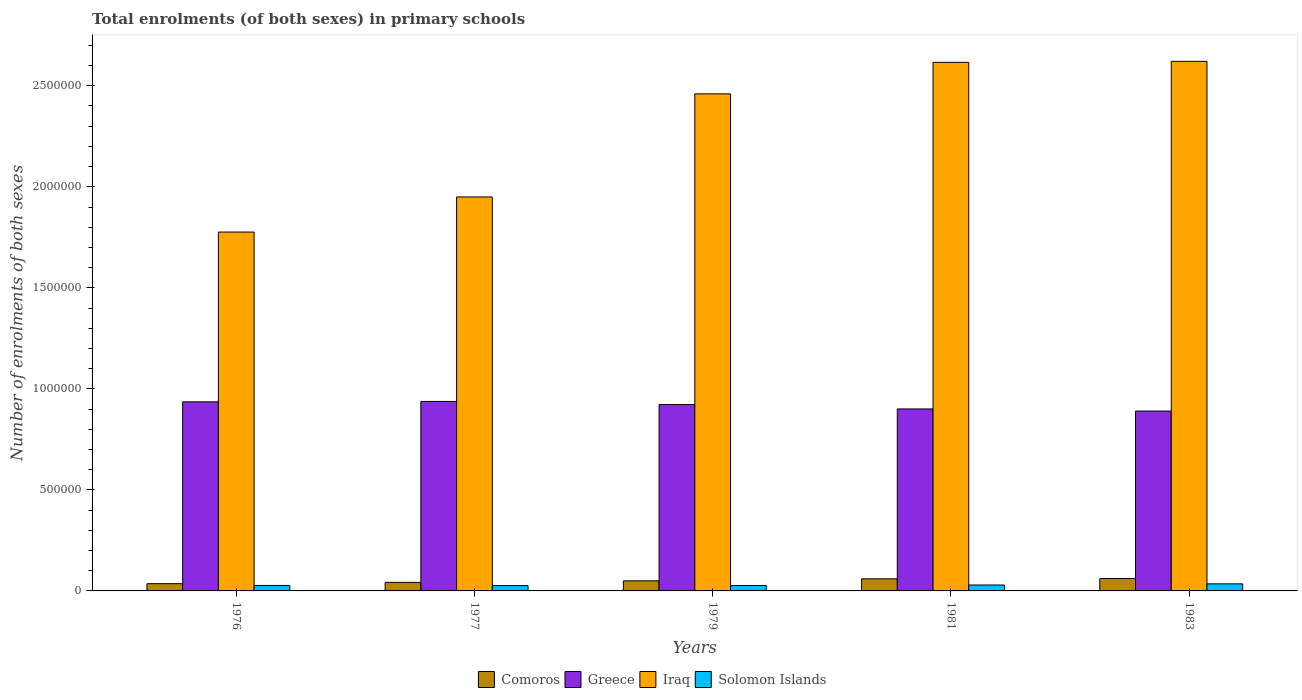How many different coloured bars are there?
Give a very brief answer. 4. How many groups of bars are there?
Offer a very short reply. 5. How many bars are there on the 3rd tick from the right?
Give a very brief answer. 4. What is the label of the 1st group of bars from the left?
Your answer should be very brief. 1976. In how many cases, is the number of bars for a given year not equal to the number of legend labels?
Your answer should be very brief. 0. What is the number of enrolments in primary schools in Comoros in 1979?
Offer a very short reply. 4.99e+04. Across all years, what is the maximum number of enrolments in primary schools in Iraq?
Your response must be concise. 2.62e+06. Across all years, what is the minimum number of enrolments in primary schools in Iraq?
Keep it short and to the point. 1.78e+06. In which year was the number of enrolments in primary schools in Iraq minimum?
Offer a terse response. 1976. What is the total number of enrolments in primary schools in Iraq in the graph?
Give a very brief answer. 1.14e+07. What is the difference between the number of enrolments in primary schools in Iraq in 1977 and that in 1979?
Offer a terse response. -5.10e+05. What is the difference between the number of enrolments in primary schools in Iraq in 1977 and the number of enrolments in primary schools in Greece in 1979?
Make the answer very short. 1.03e+06. What is the average number of enrolments in primary schools in Solomon Islands per year?
Your response must be concise. 2.89e+04. In the year 1979, what is the difference between the number of enrolments in primary schools in Solomon Islands and number of enrolments in primary schools in Comoros?
Your answer should be very brief. -2.30e+04. In how many years, is the number of enrolments in primary schools in Iraq greater than 2500000?
Give a very brief answer. 2. What is the ratio of the number of enrolments in primary schools in Iraq in 1976 to that in 1977?
Ensure brevity in your answer.  0.91. Is the number of enrolments in primary schools in Comoros in 1979 less than that in 1983?
Offer a very short reply. Yes. What is the difference between the highest and the second highest number of enrolments in primary schools in Iraq?
Offer a terse response. 4973. What is the difference between the highest and the lowest number of enrolments in primary schools in Comoros?
Give a very brief answer. 2.57e+04. Is the sum of the number of enrolments in primary schools in Greece in 1979 and 1983 greater than the maximum number of enrolments in primary schools in Solomon Islands across all years?
Provide a succinct answer. Yes. Is it the case that in every year, the sum of the number of enrolments in primary schools in Greece and number of enrolments in primary schools in Comoros is greater than the sum of number of enrolments in primary schools in Solomon Islands and number of enrolments in primary schools in Iraq?
Provide a short and direct response. Yes. What does the 1st bar from the left in 1983 represents?
Your answer should be very brief. Comoros. What does the 2nd bar from the right in 1976 represents?
Make the answer very short. Iraq. How many bars are there?
Offer a very short reply. 20. Are all the bars in the graph horizontal?
Provide a succinct answer. No. Are the values on the major ticks of Y-axis written in scientific E-notation?
Keep it short and to the point. No. Where does the legend appear in the graph?
Your answer should be compact. Bottom center. How are the legend labels stacked?
Offer a terse response. Horizontal. What is the title of the graph?
Make the answer very short. Total enrolments (of both sexes) in primary schools. What is the label or title of the X-axis?
Offer a very short reply. Years. What is the label or title of the Y-axis?
Provide a short and direct response. Number of enrolments of both sexes. What is the Number of enrolments of both sexes in Comoros in 1976?
Give a very brief answer. 3.58e+04. What is the Number of enrolments of both sexes in Greece in 1976?
Your answer should be compact. 9.36e+05. What is the Number of enrolments of both sexes in Iraq in 1976?
Provide a short and direct response. 1.78e+06. What is the Number of enrolments of both sexes of Solomon Islands in 1976?
Offer a terse response. 2.70e+04. What is the Number of enrolments of both sexes in Comoros in 1977?
Offer a very short reply. 4.23e+04. What is the Number of enrolments of both sexes of Greece in 1977?
Provide a short and direct response. 9.38e+05. What is the Number of enrolments of both sexes in Iraq in 1977?
Your answer should be compact. 1.95e+06. What is the Number of enrolments of both sexes in Solomon Islands in 1977?
Give a very brief answer. 2.64e+04. What is the Number of enrolments of both sexes of Comoros in 1979?
Give a very brief answer. 4.99e+04. What is the Number of enrolments of both sexes in Greece in 1979?
Your answer should be compact. 9.22e+05. What is the Number of enrolments of both sexes in Iraq in 1979?
Make the answer very short. 2.46e+06. What is the Number of enrolments of both sexes in Solomon Islands in 1979?
Make the answer very short. 2.70e+04. What is the Number of enrolments of both sexes in Comoros in 1981?
Give a very brief answer. 5.97e+04. What is the Number of enrolments of both sexes in Greece in 1981?
Provide a succinct answer. 9.01e+05. What is the Number of enrolments of both sexes of Iraq in 1981?
Your answer should be compact. 2.62e+06. What is the Number of enrolments of both sexes in Solomon Islands in 1981?
Your response must be concise. 2.93e+04. What is the Number of enrolments of both sexes of Comoros in 1983?
Keep it short and to the point. 6.15e+04. What is the Number of enrolments of both sexes in Greece in 1983?
Ensure brevity in your answer.  8.90e+05. What is the Number of enrolments of both sexes in Iraq in 1983?
Provide a succinct answer. 2.62e+06. What is the Number of enrolments of both sexes in Solomon Islands in 1983?
Your answer should be very brief. 3.50e+04. Across all years, what is the maximum Number of enrolments of both sexes of Comoros?
Offer a very short reply. 6.15e+04. Across all years, what is the maximum Number of enrolments of both sexes of Greece?
Provide a succinct answer. 9.38e+05. Across all years, what is the maximum Number of enrolments of both sexes of Iraq?
Your answer should be very brief. 2.62e+06. Across all years, what is the maximum Number of enrolments of both sexes of Solomon Islands?
Offer a terse response. 3.50e+04. Across all years, what is the minimum Number of enrolments of both sexes of Comoros?
Offer a terse response. 3.58e+04. Across all years, what is the minimum Number of enrolments of both sexes of Greece?
Your answer should be compact. 8.90e+05. Across all years, what is the minimum Number of enrolments of both sexes in Iraq?
Offer a very short reply. 1.78e+06. Across all years, what is the minimum Number of enrolments of both sexes in Solomon Islands?
Offer a very short reply. 2.64e+04. What is the total Number of enrolments of both sexes of Comoros in the graph?
Provide a succinct answer. 2.49e+05. What is the total Number of enrolments of both sexes in Greece in the graph?
Give a very brief answer. 4.59e+06. What is the total Number of enrolments of both sexes in Iraq in the graph?
Provide a succinct answer. 1.14e+07. What is the total Number of enrolments of both sexes in Solomon Islands in the graph?
Offer a very short reply. 1.45e+05. What is the difference between the Number of enrolments of both sexes in Comoros in 1976 and that in 1977?
Your response must be concise. -6520. What is the difference between the Number of enrolments of both sexes of Greece in 1976 and that in 1977?
Your answer should be compact. -2050. What is the difference between the Number of enrolments of both sexes in Iraq in 1976 and that in 1977?
Your answer should be compact. -1.74e+05. What is the difference between the Number of enrolments of both sexes of Solomon Islands in 1976 and that in 1977?
Provide a succinct answer. 631. What is the difference between the Number of enrolments of both sexes of Comoros in 1976 and that in 1979?
Your response must be concise. -1.41e+04. What is the difference between the Number of enrolments of both sexes of Greece in 1976 and that in 1979?
Keep it short and to the point. 1.33e+04. What is the difference between the Number of enrolments of both sexes in Iraq in 1976 and that in 1979?
Offer a terse response. -6.84e+05. What is the difference between the Number of enrolments of both sexes of Solomon Islands in 1976 and that in 1979?
Provide a succinct answer. 48. What is the difference between the Number of enrolments of both sexes of Comoros in 1976 and that in 1981?
Provide a short and direct response. -2.39e+04. What is the difference between the Number of enrolments of both sexes in Greece in 1976 and that in 1981?
Your answer should be very brief. 3.51e+04. What is the difference between the Number of enrolments of both sexes of Iraq in 1976 and that in 1981?
Ensure brevity in your answer.  -8.40e+05. What is the difference between the Number of enrolments of both sexes of Solomon Islands in 1976 and that in 1981?
Make the answer very short. -2232. What is the difference between the Number of enrolments of both sexes of Comoros in 1976 and that in 1983?
Your answer should be compact. -2.57e+04. What is the difference between the Number of enrolments of both sexes of Greece in 1976 and that in 1983?
Make the answer very short. 4.56e+04. What is the difference between the Number of enrolments of both sexes of Iraq in 1976 and that in 1983?
Make the answer very short. -8.45e+05. What is the difference between the Number of enrolments of both sexes of Solomon Islands in 1976 and that in 1983?
Provide a succinct answer. -7932. What is the difference between the Number of enrolments of both sexes in Comoros in 1977 and that in 1979?
Make the answer very short. -7602. What is the difference between the Number of enrolments of both sexes of Greece in 1977 and that in 1979?
Your answer should be very brief. 1.54e+04. What is the difference between the Number of enrolments of both sexes of Iraq in 1977 and that in 1979?
Ensure brevity in your answer.  -5.10e+05. What is the difference between the Number of enrolments of both sexes of Solomon Islands in 1977 and that in 1979?
Provide a succinct answer. -583. What is the difference between the Number of enrolments of both sexes in Comoros in 1977 and that in 1981?
Keep it short and to the point. -1.74e+04. What is the difference between the Number of enrolments of both sexes in Greece in 1977 and that in 1981?
Offer a very short reply. 3.71e+04. What is the difference between the Number of enrolments of both sexes of Iraq in 1977 and that in 1981?
Give a very brief answer. -6.66e+05. What is the difference between the Number of enrolments of both sexes in Solomon Islands in 1977 and that in 1981?
Your answer should be very brief. -2863. What is the difference between the Number of enrolments of both sexes in Comoros in 1977 and that in 1983?
Provide a short and direct response. -1.91e+04. What is the difference between the Number of enrolments of both sexes of Greece in 1977 and that in 1983?
Provide a short and direct response. 4.76e+04. What is the difference between the Number of enrolments of both sexes of Iraq in 1977 and that in 1983?
Your response must be concise. -6.71e+05. What is the difference between the Number of enrolments of both sexes of Solomon Islands in 1977 and that in 1983?
Provide a succinct answer. -8563. What is the difference between the Number of enrolments of both sexes of Comoros in 1979 and that in 1981?
Make the answer very short. -9769. What is the difference between the Number of enrolments of both sexes in Greece in 1979 and that in 1981?
Make the answer very short. 2.18e+04. What is the difference between the Number of enrolments of both sexes in Iraq in 1979 and that in 1981?
Keep it short and to the point. -1.56e+05. What is the difference between the Number of enrolments of both sexes of Solomon Islands in 1979 and that in 1981?
Ensure brevity in your answer.  -2280. What is the difference between the Number of enrolments of both sexes in Comoros in 1979 and that in 1983?
Your answer should be compact. -1.15e+04. What is the difference between the Number of enrolments of both sexes of Greece in 1979 and that in 1983?
Your answer should be very brief. 3.22e+04. What is the difference between the Number of enrolments of both sexes of Iraq in 1979 and that in 1983?
Make the answer very short. -1.61e+05. What is the difference between the Number of enrolments of both sexes of Solomon Islands in 1979 and that in 1983?
Your answer should be very brief. -7980. What is the difference between the Number of enrolments of both sexes of Comoros in 1981 and that in 1983?
Offer a very short reply. -1760. What is the difference between the Number of enrolments of both sexes in Greece in 1981 and that in 1983?
Ensure brevity in your answer.  1.05e+04. What is the difference between the Number of enrolments of both sexes of Iraq in 1981 and that in 1983?
Offer a terse response. -4973. What is the difference between the Number of enrolments of both sexes in Solomon Islands in 1981 and that in 1983?
Ensure brevity in your answer.  -5700. What is the difference between the Number of enrolments of both sexes in Comoros in 1976 and the Number of enrolments of both sexes in Greece in 1977?
Provide a succinct answer. -9.02e+05. What is the difference between the Number of enrolments of both sexes of Comoros in 1976 and the Number of enrolments of both sexes of Iraq in 1977?
Offer a very short reply. -1.91e+06. What is the difference between the Number of enrolments of both sexes in Comoros in 1976 and the Number of enrolments of both sexes in Solomon Islands in 1977?
Keep it short and to the point. 9428. What is the difference between the Number of enrolments of both sexes in Greece in 1976 and the Number of enrolments of both sexes in Iraq in 1977?
Offer a terse response. -1.01e+06. What is the difference between the Number of enrolments of both sexes of Greece in 1976 and the Number of enrolments of both sexes of Solomon Islands in 1977?
Your answer should be very brief. 9.09e+05. What is the difference between the Number of enrolments of both sexes of Iraq in 1976 and the Number of enrolments of both sexes of Solomon Islands in 1977?
Your answer should be compact. 1.75e+06. What is the difference between the Number of enrolments of both sexes in Comoros in 1976 and the Number of enrolments of both sexes in Greece in 1979?
Your answer should be very brief. -8.87e+05. What is the difference between the Number of enrolments of both sexes of Comoros in 1976 and the Number of enrolments of both sexes of Iraq in 1979?
Your response must be concise. -2.42e+06. What is the difference between the Number of enrolments of both sexes of Comoros in 1976 and the Number of enrolments of both sexes of Solomon Islands in 1979?
Give a very brief answer. 8845. What is the difference between the Number of enrolments of both sexes in Greece in 1976 and the Number of enrolments of both sexes in Iraq in 1979?
Keep it short and to the point. -1.52e+06. What is the difference between the Number of enrolments of both sexes in Greece in 1976 and the Number of enrolments of both sexes in Solomon Islands in 1979?
Provide a succinct answer. 9.09e+05. What is the difference between the Number of enrolments of both sexes in Iraq in 1976 and the Number of enrolments of both sexes in Solomon Islands in 1979?
Make the answer very short. 1.75e+06. What is the difference between the Number of enrolments of both sexes in Comoros in 1976 and the Number of enrolments of both sexes in Greece in 1981?
Provide a succinct answer. -8.65e+05. What is the difference between the Number of enrolments of both sexes in Comoros in 1976 and the Number of enrolments of both sexes in Iraq in 1981?
Your answer should be very brief. -2.58e+06. What is the difference between the Number of enrolments of both sexes of Comoros in 1976 and the Number of enrolments of both sexes of Solomon Islands in 1981?
Keep it short and to the point. 6565. What is the difference between the Number of enrolments of both sexes in Greece in 1976 and the Number of enrolments of both sexes in Iraq in 1981?
Offer a very short reply. -1.68e+06. What is the difference between the Number of enrolments of both sexes of Greece in 1976 and the Number of enrolments of both sexes of Solomon Islands in 1981?
Make the answer very short. 9.06e+05. What is the difference between the Number of enrolments of both sexes in Iraq in 1976 and the Number of enrolments of both sexes in Solomon Islands in 1981?
Give a very brief answer. 1.75e+06. What is the difference between the Number of enrolments of both sexes in Comoros in 1976 and the Number of enrolments of both sexes in Greece in 1983?
Offer a very short reply. -8.54e+05. What is the difference between the Number of enrolments of both sexes in Comoros in 1976 and the Number of enrolments of both sexes in Iraq in 1983?
Your response must be concise. -2.59e+06. What is the difference between the Number of enrolments of both sexes of Comoros in 1976 and the Number of enrolments of both sexes of Solomon Islands in 1983?
Your response must be concise. 865. What is the difference between the Number of enrolments of both sexes of Greece in 1976 and the Number of enrolments of both sexes of Iraq in 1983?
Your response must be concise. -1.69e+06. What is the difference between the Number of enrolments of both sexes in Greece in 1976 and the Number of enrolments of both sexes in Solomon Islands in 1983?
Offer a very short reply. 9.01e+05. What is the difference between the Number of enrolments of both sexes of Iraq in 1976 and the Number of enrolments of both sexes of Solomon Islands in 1983?
Your answer should be compact. 1.74e+06. What is the difference between the Number of enrolments of both sexes in Comoros in 1977 and the Number of enrolments of both sexes in Greece in 1979?
Your answer should be very brief. -8.80e+05. What is the difference between the Number of enrolments of both sexes of Comoros in 1977 and the Number of enrolments of both sexes of Iraq in 1979?
Provide a short and direct response. -2.42e+06. What is the difference between the Number of enrolments of both sexes in Comoros in 1977 and the Number of enrolments of both sexes in Solomon Islands in 1979?
Offer a terse response. 1.54e+04. What is the difference between the Number of enrolments of both sexes in Greece in 1977 and the Number of enrolments of both sexes in Iraq in 1979?
Ensure brevity in your answer.  -1.52e+06. What is the difference between the Number of enrolments of both sexes in Greece in 1977 and the Number of enrolments of both sexes in Solomon Islands in 1979?
Your answer should be compact. 9.11e+05. What is the difference between the Number of enrolments of both sexes in Iraq in 1977 and the Number of enrolments of both sexes in Solomon Islands in 1979?
Offer a terse response. 1.92e+06. What is the difference between the Number of enrolments of both sexes in Comoros in 1977 and the Number of enrolments of both sexes in Greece in 1981?
Keep it short and to the point. -8.58e+05. What is the difference between the Number of enrolments of both sexes of Comoros in 1977 and the Number of enrolments of both sexes of Iraq in 1981?
Keep it short and to the point. -2.57e+06. What is the difference between the Number of enrolments of both sexes in Comoros in 1977 and the Number of enrolments of both sexes in Solomon Islands in 1981?
Provide a short and direct response. 1.31e+04. What is the difference between the Number of enrolments of both sexes of Greece in 1977 and the Number of enrolments of both sexes of Iraq in 1981?
Provide a short and direct response. -1.68e+06. What is the difference between the Number of enrolments of both sexes in Greece in 1977 and the Number of enrolments of both sexes in Solomon Islands in 1981?
Your answer should be very brief. 9.09e+05. What is the difference between the Number of enrolments of both sexes in Iraq in 1977 and the Number of enrolments of both sexes in Solomon Islands in 1981?
Offer a terse response. 1.92e+06. What is the difference between the Number of enrolments of both sexes of Comoros in 1977 and the Number of enrolments of both sexes of Greece in 1983?
Make the answer very short. -8.48e+05. What is the difference between the Number of enrolments of both sexes of Comoros in 1977 and the Number of enrolments of both sexes of Iraq in 1983?
Make the answer very short. -2.58e+06. What is the difference between the Number of enrolments of both sexes of Comoros in 1977 and the Number of enrolments of both sexes of Solomon Islands in 1983?
Give a very brief answer. 7385. What is the difference between the Number of enrolments of both sexes of Greece in 1977 and the Number of enrolments of both sexes of Iraq in 1983?
Offer a terse response. -1.68e+06. What is the difference between the Number of enrolments of both sexes in Greece in 1977 and the Number of enrolments of both sexes in Solomon Islands in 1983?
Offer a very short reply. 9.03e+05. What is the difference between the Number of enrolments of both sexes in Iraq in 1977 and the Number of enrolments of both sexes in Solomon Islands in 1983?
Offer a very short reply. 1.91e+06. What is the difference between the Number of enrolments of both sexes in Comoros in 1979 and the Number of enrolments of both sexes in Greece in 1981?
Provide a short and direct response. -8.51e+05. What is the difference between the Number of enrolments of both sexes in Comoros in 1979 and the Number of enrolments of both sexes in Iraq in 1981?
Offer a very short reply. -2.57e+06. What is the difference between the Number of enrolments of both sexes in Comoros in 1979 and the Number of enrolments of both sexes in Solomon Islands in 1981?
Provide a short and direct response. 2.07e+04. What is the difference between the Number of enrolments of both sexes of Greece in 1979 and the Number of enrolments of both sexes of Iraq in 1981?
Keep it short and to the point. -1.69e+06. What is the difference between the Number of enrolments of both sexes of Greece in 1979 and the Number of enrolments of both sexes of Solomon Islands in 1981?
Your answer should be very brief. 8.93e+05. What is the difference between the Number of enrolments of both sexes of Iraq in 1979 and the Number of enrolments of both sexes of Solomon Islands in 1981?
Make the answer very short. 2.43e+06. What is the difference between the Number of enrolments of both sexes of Comoros in 1979 and the Number of enrolments of both sexes of Greece in 1983?
Offer a very short reply. -8.40e+05. What is the difference between the Number of enrolments of both sexes in Comoros in 1979 and the Number of enrolments of both sexes in Iraq in 1983?
Offer a terse response. -2.57e+06. What is the difference between the Number of enrolments of both sexes in Comoros in 1979 and the Number of enrolments of both sexes in Solomon Islands in 1983?
Provide a short and direct response. 1.50e+04. What is the difference between the Number of enrolments of both sexes of Greece in 1979 and the Number of enrolments of both sexes of Iraq in 1983?
Make the answer very short. -1.70e+06. What is the difference between the Number of enrolments of both sexes in Greece in 1979 and the Number of enrolments of both sexes in Solomon Islands in 1983?
Keep it short and to the point. 8.87e+05. What is the difference between the Number of enrolments of both sexes in Iraq in 1979 and the Number of enrolments of both sexes in Solomon Islands in 1983?
Ensure brevity in your answer.  2.43e+06. What is the difference between the Number of enrolments of both sexes of Comoros in 1981 and the Number of enrolments of both sexes of Greece in 1983?
Offer a terse response. -8.30e+05. What is the difference between the Number of enrolments of both sexes of Comoros in 1981 and the Number of enrolments of both sexes of Iraq in 1983?
Offer a terse response. -2.56e+06. What is the difference between the Number of enrolments of both sexes in Comoros in 1981 and the Number of enrolments of both sexes in Solomon Islands in 1983?
Your response must be concise. 2.48e+04. What is the difference between the Number of enrolments of both sexes of Greece in 1981 and the Number of enrolments of both sexes of Iraq in 1983?
Ensure brevity in your answer.  -1.72e+06. What is the difference between the Number of enrolments of both sexes of Greece in 1981 and the Number of enrolments of both sexes of Solomon Islands in 1983?
Make the answer very short. 8.66e+05. What is the difference between the Number of enrolments of both sexes in Iraq in 1981 and the Number of enrolments of both sexes in Solomon Islands in 1983?
Offer a terse response. 2.58e+06. What is the average Number of enrolments of both sexes in Comoros per year?
Provide a succinct answer. 4.99e+04. What is the average Number of enrolments of both sexes of Greece per year?
Keep it short and to the point. 9.17e+05. What is the average Number of enrolments of both sexes in Iraq per year?
Provide a short and direct response. 2.28e+06. What is the average Number of enrolments of both sexes of Solomon Islands per year?
Your response must be concise. 2.89e+04. In the year 1976, what is the difference between the Number of enrolments of both sexes in Comoros and Number of enrolments of both sexes in Greece?
Your answer should be compact. -9.00e+05. In the year 1976, what is the difference between the Number of enrolments of both sexes of Comoros and Number of enrolments of both sexes of Iraq?
Your response must be concise. -1.74e+06. In the year 1976, what is the difference between the Number of enrolments of both sexes in Comoros and Number of enrolments of both sexes in Solomon Islands?
Give a very brief answer. 8797. In the year 1976, what is the difference between the Number of enrolments of both sexes in Greece and Number of enrolments of both sexes in Iraq?
Offer a terse response. -8.40e+05. In the year 1976, what is the difference between the Number of enrolments of both sexes of Greece and Number of enrolments of both sexes of Solomon Islands?
Provide a succinct answer. 9.09e+05. In the year 1976, what is the difference between the Number of enrolments of both sexes of Iraq and Number of enrolments of both sexes of Solomon Islands?
Provide a short and direct response. 1.75e+06. In the year 1977, what is the difference between the Number of enrolments of both sexes of Comoros and Number of enrolments of both sexes of Greece?
Offer a very short reply. -8.95e+05. In the year 1977, what is the difference between the Number of enrolments of both sexes of Comoros and Number of enrolments of both sexes of Iraq?
Make the answer very short. -1.91e+06. In the year 1977, what is the difference between the Number of enrolments of both sexes in Comoros and Number of enrolments of both sexes in Solomon Islands?
Keep it short and to the point. 1.59e+04. In the year 1977, what is the difference between the Number of enrolments of both sexes of Greece and Number of enrolments of both sexes of Iraq?
Your answer should be very brief. -1.01e+06. In the year 1977, what is the difference between the Number of enrolments of both sexes in Greece and Number of enrolments of both sexes in Solomon Islands?
Provide a short and direct response. 9.11e+05. In the year 1977, what is the difference between the Number of enrolments of both sexes of Iraq and Number of enrolments of both sexes of Solomon Islands?
Provide a succinct answer. 1.92e+06. In the year 1979, what is the difference between the Number of enrolments of both sexes of Comoros and Number of enrolments of both sexes of Greece?
Your response must be concise. -8.72e+05. In the year 1979, what is the difference between the Number of enrolments of both sexes in Comoros and Number of enrolments of both sexes in Iraq?
Provide a succinct answer. -2.41e+06. In the year 1979, what is the difference between the Number of enrolments of both sexes in Comoros and Number of enrolments of both sexes in Solomon Islands?
Your response must be concise. 2.30e+04. In the year 1979, what is the difference between the Number of enrolments of both sexes in Greece and Number of enrolments of both sexes in Iraq?
Your answer should be very brief. -1.54e+06. In the year 1979, what is the difference between the Number of enrolments of both sexes of Greece and Number of enrolments of both sexes of Solomon Islands?
Provide a short and direct response. 8.95e+05. In the year 1979, what is the difference between the Number of enrolments of both sexes in Iraq and Number of enrolments of both sexes in Solomon Islands?
Keep it short and to the point. 2.43e+06. In the year 1981, what is the difference between the Number of enrolments of both sexes of Comoros and Number of enrolments of both sexes of Greece?
Offer a terse response. -8.41e+05. In the year 1981, what is the difference between the Number of enrolments of both sexes in Comoros and Number of enrolments of both sexes in Iraq?
Your response must be concise. -2.56e+06. In the year 1981, what is the difference between the Number of enrolments of both sexes in Comoros and Number of enrolments of both sexes in Solomon Islands?
Your answer should be compact. 3.05e+04. In the year 1981, what is the difference between the Number of enrolments of both sexes of Greece and Number of enrolments of both sexes of Iraq?
Provide a succinct answer. -1.72e+06. In the year 1981, what is the difference between the Number of enrolments of both sexes in Greece and Number of enrolments of both sexes in Solomon Islands?
Give a very brief answer. 8.71e+05. In the year 1981, what is the difference between the Number of enrolments of both sexes in Iraq and Number of enrolments of both sexes in Solomon Islands?
Your answer should be compact. 2.59e+06. In the year 1983, what is the difference between the Number of enrolments of both sexes in Comoros and Number of enrolments of both sexes in Greece?
Your answer should be very brief. -8.29e+05. In the year 1983, what is the difference between the Number of enrolments of both sexes of Comoros and Number of enrolments of both sexes of Iraq?
Make the answer very short. -2.56e+06. In the year 1983, what is the difference between the Number of enrolments of both sexes in Comoros and Number of enrolments of both sexes in Solomon Islands?
Offer a terse response. 2.65e+04. In the year 1983, what is the difference between the Number of enrolments of both sexes of Greece and Number of enrolments of both sexes of Iraq?
Make the answer very short. -1.73e+06. In the year 1983, what is the difference between the Number of enrolments of both sexes of Greece and Number of enrolments of both sexes of Solomon Islands?
Give a very brief answer. 8.55e+05. In the year 1983, what is the difference between the Number of enrolments of both sexes of Iraq and Number of enrolments of both sexes of Solomon Islands?
Give a very brief answer. 2.59e+06. What is the ratio of the Number of enrolments of both sexes of Comoros in 1976 to that in 1977?
Provide a succinct answer. 0.85. What is the ratio of the Number of enrolments of both sexes of Greece in 1976 to that in 1977?
Give a very brief answer. 1. What is the ratio of the Number of enrolments of both sexes of Iraq in 1976 to that in 1977?
Your response must be concise. 0.91. What is the ratio of the Number of enrolments of both sexes of Solomon Islands in 1976 to that in 1977?
Keep it short and to the point. 1.02. What is the ratio of the Number of enrolments of both sexes of Comoros in 1976 to that in 1979?
Give a very brief answer. 0.72. What is the ratio of the Number of enrolments of both sexes of Greece in 1976 to that in 1979?
Your answer should be compact. 1.01. What is the ratio of the Number of enrolments of both sexes of Iraq in 1976 to that in 1979?
Your answer should be compact. 0.72. What is the ratio of the Number of enrolments of both sexes of Comoros in 1976 to that in 1981?
Offer a very short reply. 0.6. What is the ratio of the Number of enrolments of both sexes of Greece in 1976 to that in 1981?
Provide a succinct answer. 1.04. What is the ratio of the Number of enrolments of both sexes in Iraq in 1976 to that in 1981?
Provide a short and direct response. 0.68. What is the ratio of the Number of enrolments of both sexes in Solomon Islands in 1976 to that in 1981?
Make the answer very short. 0.92. What is the ratio of the Number of enrolments of both sexes in Comoros in 1976 to that in 1983?
Keep it short and to the point. 0.58. What is the ratio of the Number of enrolments of both sexes of Greece in 1976 to that in 1983?
Your response must be concise. 1.05. What is the ratio of the Number of enrolments of both sexes in Iraq in 1976 to that in 1983?
Make the answer very short. 0.68. What is the ratio of the Number of enrolments of both sexes of Solomon Islands in 1976 to that in 1983?
Give a very brief answer. 0.77. What is the ratio of the Number of enrolments of both sexes in Comoros in 1977 to that in 1979?
Provide a short and direct response. 0.85. What is the ratio of the Number of enrolments of both sexes of Greece in 1977 to that in 1979?
Give a very brief answer. 1.02. What is the ratio of the Number of enrolments of both sexes in Iraq in 1977 to that in 1979?
Provide a short and direct response. 0.79. What is the ratio of the Number of enrolments of both sexes of Solomon Islands in 1977 to that in 1979?
Offer a terse response. 0.98. What is the ratio of the Number of enrolments of both sexes in Comoros in 1977 to that in 1981?
Ensure brevity in your answer.  0.71. What is the ratio of the Number of enrolments of both sexes in Greece in 1977 to that in 1981?
Offer a very short reply. 1.04. What is the ratio of the Number of enrolments of both sexes of Iraq in 1977 to that in 1981?
Offer a very short reply. 0.75. What is the ratio of the Number of enrolments of both sexes of Solomon Islands in 1977 to that in 1981?
Make the answer very short. 0.9. What is the ratio of the Number of enrolments of both sexes of Comoros in 1977 to that in 1983?
Your answer should be compact. 0.69. What is the ratio of the Number of enrolments of both sexes in Greece in 1977 to that in 1983?
Provide a succinct answer. 1.05. What is the ratio of the Number of enrolments of both sexes of Iraq in 1977 to that in 1983?
Your answer should be very brief. 0.74. What is the ratio of the Number of enrolments of both sexes in Solomon Islands in 1977 to that in 1983?
Your answer should be very brief. 0.76. What is the ratio of the Number of enrolments of both sexes of Comoros in 1979 to that in 1981?
Make the answer very short. 0.84. What is the ratio of the Number of enrolments of both sexes in Greece in 1979 to that in 1981?
Keep it short and to the point. 1.02. What is the ratio of the Number of enrolments of both sexes in Iraq in 1979 to that in 1981?
Your response must be concise. 0.94. What is the ratio of the Number of enrolments of both sexes in Solomon Islands in 1979 to that in 1981?
Offer a terse response. 0.92. What is the ratio of the Number of enrolments of both sexes of Comoros in 1979 to that in 1983?
Your answer should be very brief. 0.81. What is the ratio of the Number of enrolments of both sexes of Greece in 1979 to that in 1983?
Give a very brief answer. 1.04. What is the ratio of the Number of enrolments of both sexes of Iraq in 1979 to that in 1983?
Keep it short and to the point. 0.94. What is the ratio of the Number of enrolments of both sexes of Solomon Islands in 1979 to that in 1983?
Offer a very short reply. 0.77. What is the ratio of the Number of enrolments of both sexes of Comoros in 1981 to that in 1983?
Ensure brevity in your answer.  0.97. What is the ratio of the Number of enrolments of both sexes of Greece in 1981 to that in 1983?
Provide a succinct answer. 1.01. What is the ratio of the Number of enrolments of both sexes of Iraq in 1981 to that in 1983?
Your response must be concise. 1. What is the ratio of the Number of enrolments of both sexes in Solomon Islands in 1981 to that in 1983?
Your answer should be very brief. 0.84. What is the difference between the highest and the second highest Number of enrolments of both sexes in Comoros?
Your answer should be compact. 1760. What is the difference between the highest and the second highest Number of enrolments of both sexes of Greece?
Your answer should be very brief. 2050. What is the difference between the highest and the second highest Number of enrolments of both sexes in Iraq?
Keep it short and to the point. 4973. What is the difference between the highest and the second highest Number of enrolments of both sexes in Solomon Islands?
Offer a terse response. 5700. What is the difference between the highest and the lowest Number of enrolments of both sexes of Comoros?
Your response must be concise. 2.57e+04. What is the difference between the highest and the lowest Number of enrolments of both sexes of Greece?
Your answer should be very brief. 4.76e+04. What is the difference between the highest and the lowest Number of enrolments of both sexes of Iraq?
Give a very brief answer. 8.45e+05. What is the difference between the highest and the lowest Number of enrolments of both sexes in Solomon Islands?
Provide a short and direct response. 8563. 